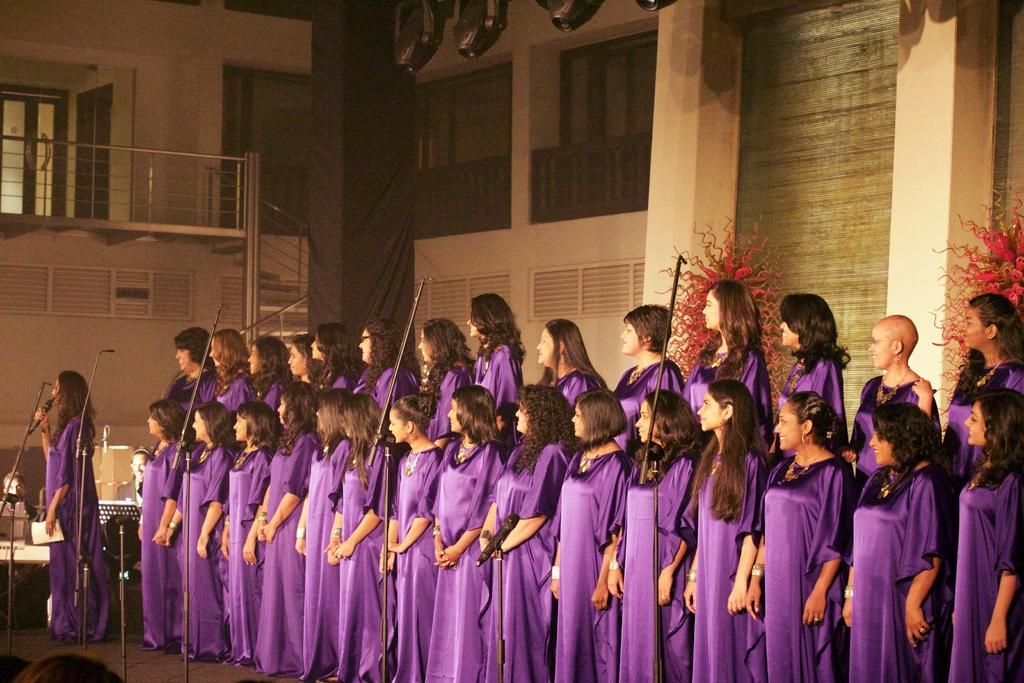Who is present in the image? There are ladies in the image. What are the ladies wearing? The ladies are wearing gowns. What can be seen in the background of the image? There are windows in the image. What type of architectural feature is present in the image? There is fencing in the image. What other elements can be seen in the image? There are plants and stands present in the image. Can you tell me how many umbrellas the ladies are holding in the image? There is no mention of umbrellas in the image; the ladies are not holding any. What type of balance do the plants have in the image? The plants do not exhibit any specific type of balance in the image; they are simply present. 